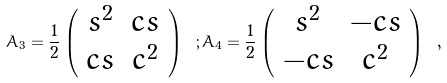Convert formula to latex. <formula><loc_0><loc_0><loc_500><loc_500>A _ { 3 } = \frac { 1 } { 2 } \left ( \begin{array} { c c } s ^ { 2 } & c s \\ c s & c ^ { 2 } \end{array} \right ) \ ; A _ { 4 } = \frac { 1 } { 2 } \left ( \begin{array} { c c } s ^ { 2 } & - c s \\ - c s & c ^ { 2 } \end{array} \right ) \ ,</formula> 